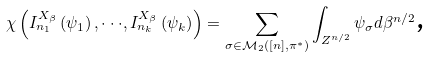Convert formula to latex. <formula><loc_0><loc_0><loc_500><loc_500>\mathbb { \chi } \left ( I _ { n _ { 1 } } ^ { X _ { \beta } } \left ( \psi _ { 1 } \right ) , \cdot \cdot \cdot , I _ { n _ { k } } ^ { X _ { \beta } } \left ( \psi _ { k } \right ) \right ) = \sum _ { \sigma \in \mathcal { M } _ { 2 } \left ( \left [ n \right ] , \pi ^ { \ast } \right ) } \int _ { Z ^ { n / 2 } } \psi _ { \sigma } d \beta ^ { n / 2 } \text {,}</formula> 